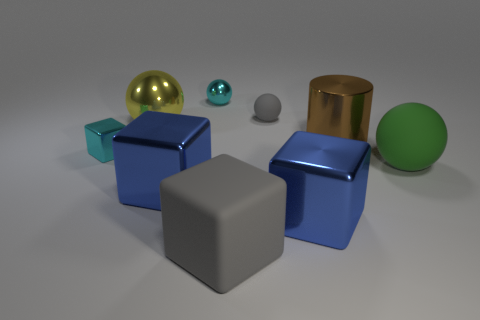Subtract 1 spheres. How many spheres are left? 3 Add 1 cyan spheres. How many objects exist? 10 Subtract all cubes. How many objects are left? 5 Add 9 yellow spheres. How many yellow spheres exist? 10 Subtract 1 cyan blocks. How many objects are left? 8 Subtract all large red cubes. Subtract all small gray matte objects. How many objects are left? 8 Add 1 big things. How many big things are left? 7 